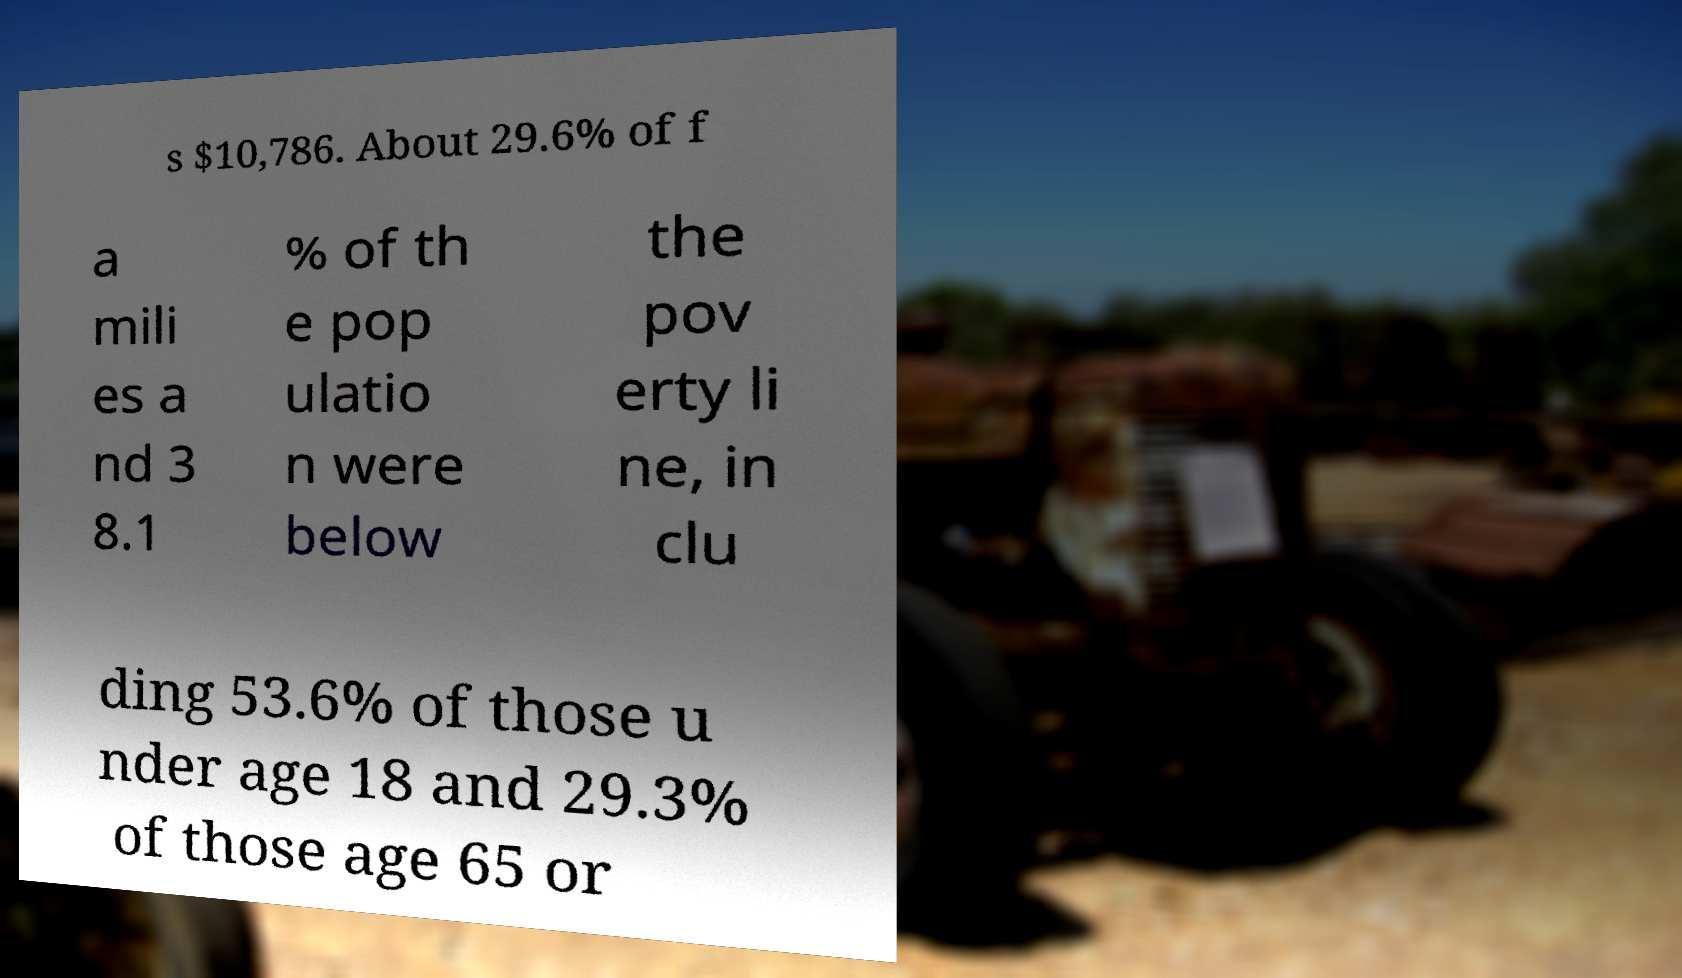Can you read and provide the text displayed in the image?This photo seems to have some interesting text. Can you extract and type it out for me? s $10,786. About 29.6% of f a mili es a nd 3 8.1 % of th e pop ulatio n were below the pov erty li ne, in clu ding 53.6% of those u nder age 18 and 29.3% of those age 65 or 